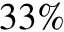Convert formula to latex. <formula><loc_0><loc_0><loc_500><loc_500>3 3 \%</formula> 